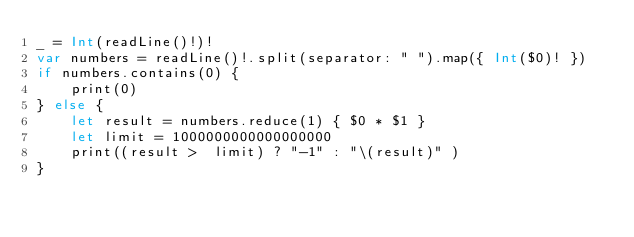<code> <loc_0><loc_0><loc_500><loc_500><_Swift_>_ = Int(readLine()!)!
var numbers = readLine()!.split(separator: " ").map({ Int($0)! })
if numbers.contains(0) {
    print(0)
} else {
    let result = numbers.reduce(1) { $0 * $1 }
    let limit = 1000000000000000000
    print((result >  limit) ? "-1" : "\(result)" )
}
</code> 